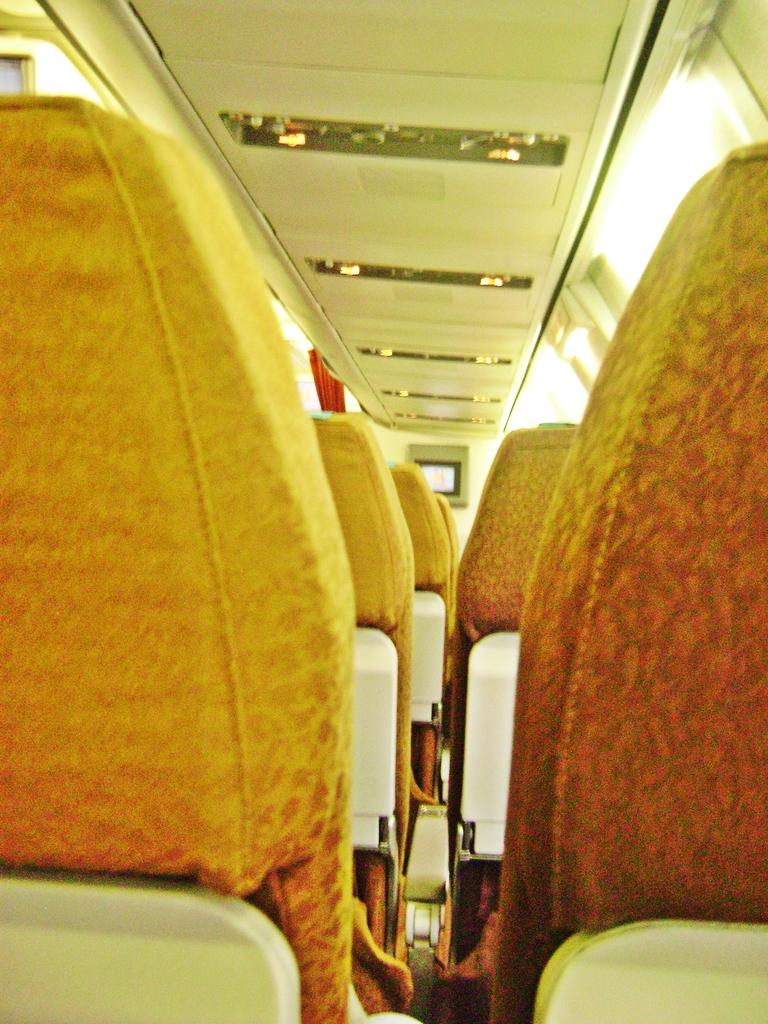Where was the image taken? The image was taken inside a flight. What can be seen in the image besides the interior of the flight? There are seats, windows, and a screen visible in the image. What type of toy can be seen on the floor in the image? There is no toy present on the floor in the image. Is there a bomb visible in the image? No, there is no bomb present in the image. 